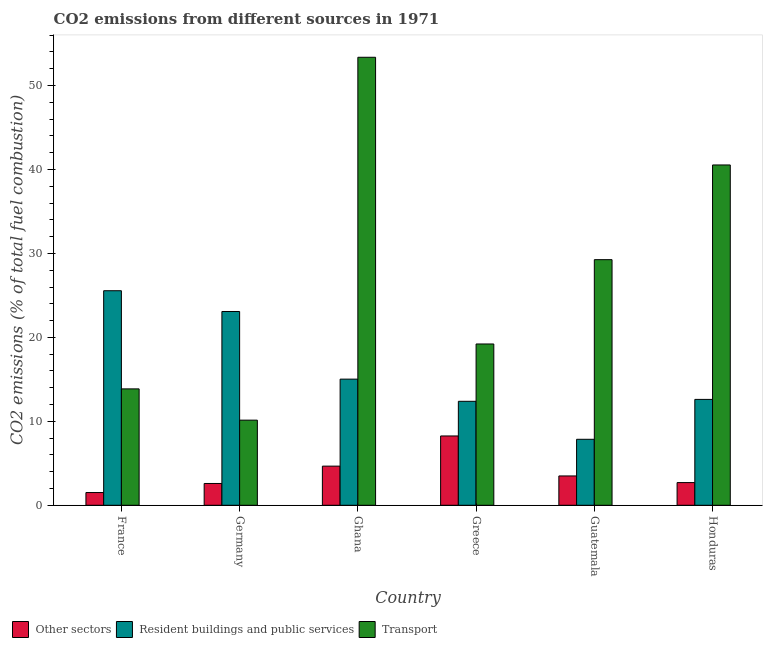How many groups of bars are there?
Your answer should be compact. 6. In how many cases, is the number of bars for a given country not equal to the number of legend labels?
Provide a succinct answer. 0. What is the percentage of co2 emissions from resident buildings and public services in Honduras?
Your answer should be very brief. 12.61. Across all countries, what is the maximum percentage of co2 emissions from transport?
Provide a succinct answer. 53.37. Across all countries, what is the minimum percentage of co2 emissions from other sectors?
Your response must be concise. 1.52. What is the total percentage of co2 emissions from transport in the graph?
Your answer should be compact. 166.39. What is the difference between the percentage of co2 emissions from other sectors in Germany and that in Honduras?
Your answer should be compact. -0.11. What is the difference between the percentage of co2 emissions from resident buildings and public services in Honduras and the percentage of co2 emissions from other sectors in France?
Your response must be concise. 11.1. What is the average percentage of co2 emissions from other sectors per country?
Your answer should be compact. 3.87. What is the difference between the percentage of co2 emissions from transport and percentage of co2 emissions from resident buildings and public services in Greece?
Your response must be concise. 6.83. What is the ratio of the percentage of co2 emissions from other sectors in Ghana to that in Guatemala?
Provide a short and direct response. 1.33. What is the difference between the highest and the second highest percentage of co2 emissions from transport?
Your answer should be compact. 12.83. What is the difference between the highest and the lowest percentage of co2 emissions from transport?
Give a very brief answer. 43.23. What does the 3rd bar from the left in Ghana represents?
Ensure brevity in your answer.  Transport. What does the 2nd bar from the right in Honduras represents?
Your answer should be compact. Resident buildings and public services. How many bars are there?
Provide a short and direct response. 18. How many countries are there in the graph?
Your response must be concise. 6. What is the difference between two consecutive major ticks on the Y-axis?
Ensure brevity in your answer.  10. Does the graph contain grids?
Your response must be concise. No. Where does the legend appear in the graph?
Offer a very short reply. Bottom left. How are the legend labels stacked?
Give a very brief answer. Horizontal. What is the title of the graph?
Make the answer very short. CO2 emissions from different sources in 1971. What is the label or title of the Y-axis?
Your answer should be compact. CO2 emissions (% of total fuel combustion). What is the CO2 emissions (% of total fuel combustion) of Other sectors in France?
Your response must be concise. 1.52. What is the CO2 emissions (% of total fuel combustion) of Resident buildings and public services in France?
Provide a succinct answer. 25.56. What is the CO2 emissions (% of total fuel combustion) in Transport in France?
Provide a short and direct response. 13.86. What is the CO2 emissions (% of total fuel combustion) in Other sectors in Germany?
Offer a terse response. 2.6. What is the CO2 emissions (% of total fuel combustion) in Resident buildings and public services in Germany?
Provide a short and direct response. 23.08. What is the CO2 emissions (% of total fuel combustion) of Transport in Germany?
Give a very brief answer. 10.14. What is the CO2 emissions (% of total fuel combustion) of Other sectors in Ghana?
Your response must be concise. 4.66. What is the CO2 emissions (% of total fuel combustion) in Resident buildings and public services in Ghana?
Give a very brief answer. 15.03. What is the CO2 emissions (% of total fuel combustion) in Transport in Ghana?
Keep it short and to the point. 53.37. What is the CO2 emissions (% of total fuel combustion) of Other sectors in Greece?
Offer a very short reply. 8.26. What is the CO2 emissions (% of total fuel combustion) in Resident buildings and public services in Greece?
Your answer should be compact. 12.39. What is the CO2 emissions (% of total fuel combustion) in Transport in Greece?
Ensure brevity in your answer.  19.21. What is the CO2 emissions (% of total fuel combustion) in Other sectors in Guatemala?
Ensure brevity in your answer.  3.49. What is the CO2 emissions (% of total fuel combustion) in Resident buildings and public services in Guatemala?
Offer a very short reply. 7.86. What is the CO2 emissions (% of total fuel combustion) in Transport in Guatemala?
Provide a succinct answer. 29.26. What is the CO2 emissions (% of total fuel combustion) of Other sectors in Honduras?
Your answer should be compact. 2.7. What is the CO2 emissions (% of total fuel combustion) of Resident buildings and public services in Honduras?
Make the answer very short. 12.61. What is the CO2 emissions (% of total fuel combustion) of Transport in Honduras?
Your answer should be compact. 40.54. Across all countries, what is the maximum CO2 emissions (% of total fuel combustion) of Other sectors?
Your response must be concise. 8.26. Across all countries, what is the maximum CO2 emissions (% of total fuel combustion) in Resident buildings and public services?
Keep it short and to the point. 25.56. Across all countries, what is the maximum CO2 emissions (% of total fuel combustion) of Transport?
Your answer should be very brief. 53.37. Across all countries, what is the minimum CO2 emissions (% of total fuel combustion) in Other sectors?
Give a very brief answer. 1.52. Across all countries, what is the minimum CO2 emissions (% of total fuel combustion) in Resident buildings and public services?
Give a very brief answer. 7.86. Across all countries, what is the minimum CO2 emissions (% of total fuel combustion) in Transport?
Your response must be concise. 10.14. What is the total CO2 emissions (% of total fuel combustion) of Other sectors in the graph?
Offer a terse response. 23.23. What is the total CO2 emissions (% of total fuel combustion) in Resident buildings and public services in the graph?
Keep it short and to the point. 96.53. What is the total CO2 emissions (% of total fuel combustion) of Transport in the graph?
Make the answer very short. 166.39. What is the difference between the CO2 emissions (% of total fuel combustion) in Other sectors in France and that in Germany?
Give a very brief answer. -1.08. What is the difference between the CO2 emissions (% of total fuel combustion) of Resident buildings and public services in France and that in Germany?
Ensure brevity in your answer.  2.47. What is the difference between the CO2 emissions (% of total fuel combustion) of Transport in France and that in Germany?
Your answer should be compact. 3.72. What is the difference between the CO2 emissions (% of total fuel combustion) in Other sectors in France and that in Ghana?
Make the answer very short. -3.15. What is the difference between the CO2 emissions (% of total fuel combustion) of Resident buildings and public services in France and that in Ghana?
Keep it short and to the point. 10.53. What is the difference between the CO2 emissions (% of total fuel combustion) of Transport in France and that in Ghana?
Your answer should be compact. -39.5. What is the difference between the CO2 emissions (% of total fuel combustion) of Other sectors in France and that in Greece?
Provide a succinct answer. -6.74. What is the difference between the CO2 emissions (% of total fuel combustion) of Resident buildings and public services in France and that in Greece?
Ensure brevity in your answer.  13.17. What is the difference between the CO2 emissions (% of total fuel combustion) of Transport in France and that in Greece?
Offer a terse response. -5.35. What is the difference between the CO2 emissions (% of total fuel combustion) in Other sectors in France and that in Guatemala?
Make the answer very short. -1.98. What is the difference between the CO2 emissions (% of total fuel combustion) of Resident buildings and public services in France and that in Guatemala?
Give a very brief answer. 17.7. What is the difference between the CO2 emissions (% of total fuel combustion) of Transport in France and that in Guatemala?
Your response must be concise. -15.39. What is the difference between the CO2 emissions (% of total fuel combustion) of Other sectors in France and that in Honduras?
Your response must be concise. -1.19. What is the difference between the CO2 emissions (% of total fuel combustion) in Resident buildings and public services in France and that in Honduras?
Your response must be concise. 12.94. What is the difference between the CO2 emissions (% of total fuel combustion) in Transport in France and that in Honduras?
Your answer should be compact. -26.68. What is the difference between the CO2 emissions (% of total fuel combustion) in Other sectors in Germany and that in Ghana?
Offer a very short reply. -2.07. What is the difference between the CO2 emissions (% of total fuel combustion) in Resident buildings and public services in Germany and that in Ghana?
Provide a succinct answer. 8.06. What is the difference between the CO2 emissions (% of total fuel combustion) of Transport in Germany and that in Ghana?
Provide a succinct answer. -43.23. What is the difference between the CO2 emissions (% of total fuel combustion) in Other sectors in Germany and that in Greece?
Keep it short and to the point. -5.66. What is the difference between the CO2 emissions (% of total fuel combustion) of Resident buildings and public services in Germany and that in Greece?
Give a very brief answer. 10.7. What is the difference between the CO2 emissions (% of total fuel combustion) in Transport in Germany and that in Greece?
Make the answer very short. -9.07. What is the difference between the CO2 emissions (% of total fuel combustion) in Other sectors in Germany and that in Guatemala?
Offer a terse response. -0.9. What is the difference between the CO2 emissions (% of total fuel combustion) of Resident buildings and public services in Germany and that in Guatemala?
Provide a short and direct response. 15.22. What is the difference between the CO2 emissions (% of total fuel combustion) of Transport in Germany and that in Guatemala?
Provide a short and direct response. -19.12. What is the difference between the CO2 emissions (% of total fuel combustion) in Other sectors in Germany and that in Honduras?
Offer a terse response. -0.11. What is the difference between the CO2 emissions (% of total fuel combustion) of Resident buildings and public services in Germany and that in Honduras?
Offer a terse response. 10.47. What is the difference between the CO2 emissions (% of total fuel combustion) in Transport in Germany and that in Honduras?
Give a very brief answer. -30.4. What is the difference between the CO2 emissions (% of total fuel combustion) in Other sectors in Ghana and that in Greece?
Your answer should be very brief. -3.59. What is the difference between the CO2 emissions (% of total fuel combustion) of Resident buildings and public services in Ghana and that in Greece?
Ensure brevity in your answer.  2.64. What is the difference between the CO2 emissions (% of total fuel combustion) in Transport in Ghana and that in Greece?
Keep it short and to the point. 34.15. What is the difference between the CO2 emissions (% of total fuel combustion) of Other sectors in Ghana and that in Guatemala?
Offer a very short reply. 1.17. What is the difference between the CO2 emissions (% of total fuel combustion) in Resident buildings and public services in Ghana and that in Guatemala?
Offer a very short reply. 7.17. What is the difference between the CO2 emissions (% of total fuel combustion) of Transport in Ghana and that in Guatemala?
Ensure brevity in your answer.  24.11. What is the difference between the CO2 emissions (% of total fuel combustion) of Other sectors in Ghana and that in Honduras?
Ensure brevity in your answer.  1.96. What is the difference between the CO2 emissions (% of total fuel combustion) in Resident buildings and public services in Ghana and that in Honduras?
Offer a very short reply. 2.41. What is the difference between the CO2 emissions (% of total fuel combustion) in Transport in Ghana and that in Honduras?
Keep it short and to the point. 12.83. What is the difference between the CO2 emissions (% of total fuel combustion) in Other sectors in Greece and that in Guatemala?
Ensure brevity in your answer.  4.76. What is the difference between the CO2 emissions (% of total fuel combustion) in Resident buildings and public services in Greece and that in Guatemala?
Provide a short and direct response. 4.53. What is the difference between the CO2 emissions (% of total fuel combustion) in Transport in Greece and that in Guatemala?
Your answer should be compact. -10.04. What is the difference between the CO2 emissions (% of total fuel combustion) in Other sectors in Greece and that in Honduras?
Keep it short and to the point. 5.55. What is the difference between the CO2 emissions (% of total fuel combustion) in Resident buildings and public services in Greece and that in Honduras?
Provide a short and direct response. -0.23. What is the difference between the CO2 emissions (% of total fuel combustion) in Transport in Greece and that in Honduras?
Offer a terse response. -21.33. What is the difference between the CO2 emissions (% of total fuel combustion) in Other sectors in Guatemala and that in Honduras?
Keep it short and to the point. 0.79. What is the difference between the CO2 emissions (% of total fuel combustion) in Resident buildings and public services in Guatemala and that in Honduras?
Offer a very short reply. -4.75. What is the difference between the CO2 emissions (% of total fuel combustion) of Transport in Guatemala and that in Honduras?
Offer a very short reply. -11.28. What is the difference between the CO2 emissions (% of total fuel combustion) in Other sectors in France and the CO2 emissions (% of total fuel combustion) in Resident buildings and public services in Germany?
Make the answer very short. -21.57. What is the difference between the CO2 emissions (% of total fuel combustion) in Other sectors in France and the CO2 emissions (% of total fuel combustion) in Transport in Germany?
Provide a succinct answer. -8.62. What is the difference between the CO2 emissions (% of total fuel combustion) in Resident buildings and public services in France and the CO2 emissions (% of total fuel combustion) in Transport in Germany?
Ensure brevity in your answer.  15.42. What is the difference between the CO2 emissions (% of total fuel combustion) of Other sectors in France and the CO2 emissions (% of total fuel combustion) of Resident buildings and public services in Ghana?
Your answer should be very brief. -13.51. What is the difference between the CO2 emissions (% of total fuel combustion) of Other sectors in France and the CO2 emissions (% of total fuel combustion) of Transport in Ghana?
Make the answer very short. -51.85. What is the difference between the CO2 emissions (% of total fuel combustion) in Resident buildings and public services in France and the CO2 emissions (% of total fuel combustion) in Transport in Ghana?
Keep it short and to the point. -27.81. What is the difference between the CO2 emissions (% of total fuel combustion) in Other sectors in France and the CO2 emissions (% of total fuel combustion) in Resident buildings and public services in Greece?
Offer a very short reply. -10.87. What is the difference between the CO2 emissions (% of total fuel combustion) in Other sectors in France and the CO2 emissions (% of total fuel combustion) in Transport in Greece?
Provide a succinct answer. -17.7. What is the difference between the CO2 emissions (% of total fuel combustion) in Resident buildings and public services in France and the CO2 emissions (% of total fuel combustion) in Transport in Greece?
Ensure brevity in your answer.  6.34. What is the difference between the CO2 emissions (% of total fuel combustion) in Other sectors in France and the CO2 emissions (% of total fuel combustion) in Resident buildings and public services in Guatemala?
Your answer should be compact. -6.34. What is the difference between the CO2 emissions (% of total fuel combustion) of Other sectors in France and the CO2 emissions (% of total fuel combustion) of Transport in Guatemala?
Keep it short and to the point. -27.74. What is the difference between the CO2 emissions (% of total fuel combustion) in Resident buildings and public services in France and the CO2 emissions (% of total fuel combustion) in Transport in Guatemala?
Keep it short and to the point. -3.7. What is the difference between the CO2 emissions (% of total fuel combustion) of Other sectors in France and the CO2 emissions (% of total fuel combustion) of Resident buildings and public services in Honduras?
Ensure brevity in your answer.  -11.1. What is the difference between the CO2 emissions (% of total fuel combustion) in Other sectors in France and the CO2 emissions (% of total fuel combustion) in Transport in Honduras?
Your answer should be compact. -39.02. What is the difference between the CO2 emissions (% of total fuel combustion) of Resident buildings and public services in France and the CO2 emissions (% of total fuel combustion) of Transport in Honduras?
Provide a short and direct response. -14.98. What is the difference between the CO2 emissions (% of total fuel combustion) of Other sectors in Germany and the CO2 emissions (% of total fuel combustion) of Resident buildings and public services in Ghana?
Offer a terse response. -12.43. What is the difference between the CO2 emissions (% of total fuel combustion) of Other sectors in Germany and the CO2 emissions (% of total fuel combustion) of Transport in Ghana?
Keep it short and to the point. -50.77. What is the difference between the CO2 emissions (% of total fuel combustion) of Resident buildings and public services in Germany and the CO2 emissions (% of total fuel combustion) of Transport in Ghana?
Ensure brevity in your answer.  -30.28. What is the difference between the CO2 emissions (% of total fuel combustion) of Other sectors in Germany and the CO2 emissions (% of total fuel combustion) of Resident buildings and public services in Greece?
Ensure brevity in your answer.  -9.79. What is the difference between the CO2 emissions (% of total fuel combustion) of Other sectors in Germany and the CO2 emissions (% of total fuel combustion) of Transport in Greece?
Your answer should be very brief. -16.62. What is the difference between the CO2 emissions (% of total fuel combustion) in Resident buildings and public services in Germany and the CO2 emissions (% of total fuel combustion) in Transport in Greece?
Provide a succinct answer. 3.87. What is the difference between the CO2 emissions (% of total fuel combustion) of Other sectors in Germany and the CO2 emissions (% of total fuel combustion) of Resident buildings and public services in Guatemala?
Ensure brevity in your answer.  -5.26. What is the difference between the CO2 emissions (% of total fuel combustion) in Other sectors in Germany and the CO2 emissions (% of total fuel combustion) in Transport in Guatemala?
Ensure brevity in your answer.  -26.66. What is the difference between the CO2 emissions (% of total fuel combustion) in Resident buildings and public services in Germany and the CO2 emissions (% of total fuel combustion) in Transport in Guatemala?
Keep it short and to the point. -6.17. What is the difference between the CO2 emissions (% of total fuel combustion) of Other sectors in Germany and the CO2 emissions (% of total fuel combustion) of Resident buildings and public services in Honduras?
Provide a succinct answer. -10.02. What is the difference between the CO2 emissions (% of total fuel combustion) in Other sectors in Germany and the CO2 emissions (% of total fuel combustion) in Transport in Honduras?
Keep it short and to the point. -37.94. What is the difference between the CO2 emissions (% of total fuel combustion) in Resident buildings and public services in Germany and the CO2 emissions (% of total fuel combustion) in Transport in Honduras?
Provide a succinct answer. -17.46. What is the difference between the CO2 emissions (% of total fuel combustion) in Other sectors in Ghana and the CO2 emissions (% of total fuel combustion) in Resident buildings and public services in Greece?
Offer a terse response. -7.72. What is the difference between the CO2 emissions (% of total fuel combustion) of Other sectors in Ghana and the CO2 emissions (% of total fuel combustion) of Transport in Greece?
Your answer should be compact. -14.55. What is the difference between the CO2 emissions (% of total fuel combustion) of Resident buildings and public services in Ghana and the CO2 emissions (% of total fuel combustion) of Transport in Greece?
Offer a very short reply. -4.19. What is the difference between the CO2 emissions (% of total fuel combustion) in Other sectors in Ghana and the CO2 emissions (% of total fuel combustion) in Resident buildings and public services in Guatemala?
Make the answer very short. -3.2. What is the difference between the CO2 emissions (% of total fuel combustion) in Other sectors in Ghana and the CO2 emissions (% of total fuel combustion) in Transport in Guatemala?
Offer a terse response. -24.59. What is the difference between the CO2 emissions (% of total fuel combustion) in Resident buildings and public services in Ghana and the CO2 emissions (% of total fuel combustion) in Transport in Guatemala?
Your answer should be very brief. -14.23. What is the difference between the CO2 emissions (% of total fuel combustion) in Other sectors in Ghana and the CO2 emissions (% of total fuel combustion) in Resident buildings and public services in Honduras?
Make the answer very short. -7.95. What is the difference between the CO2 emissions (% of total fuel combustion) of Other sectors in Ghana and the CO2 emissions (% of total fuel combustion) of Transport in Honduras?
Ensure brevity in your answer.  -35.88. What is the difference between the CO2 emissions (% of total fuel combustion) of Resident buildings and public services in Ghana and the CO2 emissions (% of total fuel combustion) of Transport in Honduras?
Give a very brief answer. -25.51. What is the difference between the CO2 emissions (% of total fuel combustion) in Other sectors in Greece and the CO2 emissions (% of total fuel combustion) in Resident buildings and public services in Guatemala?
Provide a short and direct response. 0.4. What is the difference between the CO2 emissions (% of total fuel combustion) in Other sectors in Greece and the CO2 emissions (% of total fuel combustion) in Transport in Guatemala?
Make the answer very short. -21. What is the difference between the CO2 emissions (% of total fuel combustion) of Resident buildings and public services in Greece and the CO2 emissions (% of total fuel combustion) of Transport in Guatemala?
Offer a terse response. -16.87. What is the difference between the CO2 emissions (% of total fuel combustion) in Other sectors in Greece and the CO2 emissions (% of total fuel combustion) in Resident buildings and public services in Honduras?
Provide a short and direct response. -4.36. What is the difference between the CO2 emissions (% of total fuel combustion) of Other sectors in Greece and the CO2 emissions (% of total fuel combustion) of Transport in Honduras?
Offer a very short reply. -32.28. What is the difference between the CO2 emissions (% of total fuel combustion) of Resident buildings and public services in Greece and the CO2 emissions (% of total fuel combustion) of Transport in Honduras?
Provide a succinct answer. -28.15. What is the difference between the CO2 emissions (% of total fuel combustion) of Other sectors in Guatemala and the CO2 emissions (% of total fuel combustion) of Resident buildings and public services in Honduras?
Provide a succinct answer. -9.12. What is the difference between the CO2 emissions (% of total fuel combustion) in Other sectors in Guatemala and the CO2 emissions (% of total fuel combustion) in Transport in Honduras?
Give a very brief answer. -37.05. What is the difference between the CO2 emissions (% of total fuel combustion) in Resident buildings and public services in Guatemala and the CO2 emissions (% of total fuel combustion) in Transport in Honduras?
Offer a terse response. -32.68. What is the average CO2 emissions (% of total fuel combustion) in Other sectors per country?
Your answer should be compact. 3.87. What is the average CO2 emissions (% of total fuel combustion) of Resident buildings and public services per country?
Your response must be concise. 16.09. What is the average CO2 emissions (% of total fuel combustion) of Transport per country?
Ensure brevity in your answer.  27.73. What is the difference between the CO2 emissions (% of total fuel combustion) in Other sectors and CO2 emissions (% of total fuel combustion) in Resident buildings and public services in France?
Offer a terse response. -24.04. What is the difference between the CO2 emissions (% of total fuel combustion) in Other sectors and CO2 emissions (% of total fuel combustion) in Transport in France?
Your answer should be very brief. -12.35. What is the difference between the CO2 emissions (% of total fuel combustion) in Resident buildings and public services and CO2 emissions (% of total fuel combustion) in Transport in France?
Make the answer very short. 11.69. What is the difference between the CO2 emissions (% of total fuel combustion) in Other sectors and CO2 emissions (% of total fuel combustion) in Resident buildings and public services in Germany?
Give a very brief answer. -20.49. What is the difference between the CO2 emissions (% of total fuel combustion) of Other sectors and CO2 emissions (% of total fuel combustion) of Transport in Germany?
Offer a very short reply. -7.54. What is the difference between the CO2 emissions (% of total fuel combustion) of Resident buildings and public services and CO2 emissions (% of total fuel combustion) of Transport in Germany?
Provide a short and direct response. 12.94. What is the difference between the CO2 emissions (% of total fuel combustion) in Other sectors and CO2 emissions (% of total fuel combustion) in Resident buildings and public services in Ghana?
Your response must be concise. -10.36. What is the difference between the CO2 emissions (% of total fuel combustion) in Other sectors and CO2 emissions (% of total fuel combustion) in Transport in Ghana?
Provide a short and direct response. -48.7. What is the difference between the CO2 emissions (% of total fuel combustion) of Resident buildings and public services and CO2 emissions (% of total fuel combustion) of Transport in Ghana?
Ensure brevity in your answer.  -38.34. What is the difference between the CO2 emissions (% of total fuel combustion) in Other sectors and CO2 emissions (% of total fuel combustion) in Resident buildings and public services in Greece?
Your answer should be very brief. -4.13. What is the difference between the CO2 emissions (% of total fuel combustion) of Other sectors and CO2 emissions (% of total fuel combustion) of Transport in Greece?
Your answer should be compact. -10.96. What is the difference between the CO2 emissions (% of total fuel combustion) in Resident buildings and public services and CO2 emissions (% of total fuel combustion) in Transport in Greece?
Your answer should be very brief. -6.83. What is the difference between the CO2 emissions (% of total fuel combustion) of Other sectors and CO2 emissions (% of total fuel combustion) of Resident buildings and public services in Guatemala?
Offer a very short reply. -4.37. What is the difference between the CO2 emissions (% of total fuel combustion) in Other sectors and CO2 emissions (% of total fuel combustion) in Transport in Guatemala?
Offer a terse response. -25.76. What is the difference between the CO2 emissions (% of total fuel combustion) of Resident buildings and public services and CO2 emissions (% of total fuel combustion) of Transport in Guatemala?
Provide a short and direct response. -21.4. What is the difference between the CO2 emissions (% of total fuel combustion) in Other sectors and CO2 emissions (% of total fuel combustion) in Resident buildings and public services in Honduras?
Provide a succinct answer. -9.91. What is the difference between the CO2 emissions (% of total fuel combustion) in Other sectors and CO2 emissions (% of total fuel combustion) in Transport in Honduras?
Your answer should be very brief. -37.84. What is the difference between the CO2 emissions (% of total fuel combustion) in Resident buildings and public services and CO2 emissions (% of total fuel combustion) in Transport in Honduras?
Offer a terse response. -27.93. What is the ratio of the CO2 emissions (% of total fuel combustion) of Other sectors in France to that in Germany?
Provide a short and direct response. 0.58. What is the ratio of the CO2 emissions (% of total fuel combustion) of Resident buildings and public services in France to that in Germany?
Offer a very short reply. 1.11. What is the ratio of the CO2 emissions (% of total fuel combustion) in Transport in France to that in Germany?
Offer a very short reply. 1.37. What is the ratio of the CO2 emissions (% of total fuel combustion) of Other sectors in France to that in Ghana?
Give a very brief answer. 0.33. What is the ratio of the CO2 emissions (% of total fuel combustion) in Resident buildings and public services in France to that in Ghana?
Ensure brevity in your answer.  1.7. What is the ratio of the CO2 emissions (% of total fuel combustion) in Transport in France to that in Ghana?
Make the answer very short. 0.26. What is the ratio of the CO2 emissions (% of total fuel combustion) in Other sectors in France to that in Greece?
Give a very brief answer. 0.18. What is the ratio of the CO2 emissions (% of total fuel combustion) of Resident buildings and public services in France to that in Greece?
Keep it short and to the point. 2.06. What is the ratio of the CO2 emissions (% of total fuel combustion) in Transport in France to that in Greece?
Keep it short and to the point. 0.72. What is the ratio of the CO2 emissions (% of total fuel combustion) in Other sectors in France to that in Guatemala?
Ensure brevity in your answer.  0.43. What is the ratio of the CO2 emissions (% of total fuel combustion) of Resident buildings and public services in France to that in Guatemala?
Provide a succinct answer. 3.25. What is the ratio of the CO2 emissions (% of total fuel combustion) of Transport in France to that in Guatemala?
Keep it short and to the point. 0.47. What is the ratio of the CO2 emissions (% of total fuel combustion) in Other sectors in France to that in Honduras?
Make the answer very short. 0.56. What is the ratio of the CO2 emissions (% of total fuel combustion) of Resident buildings and public services in France to that in Honduras?
Provide a short and direct response. 2.03. What is the ratio of the CO2 emissions (% of total fuel combustion) of Transport in France to that in Honduras?
Offer a very short reply. 0.34. What is the ratio of the CO2 emissions (% of total fuel combustion) of Other sectors in Germany to that in Ghana?
Keep it short and to the point. 0.56. What is the ratio of the CO2 emissions (% of total fuel combustion) in Resident buildings and public services in Germany to that in Ghana?
Offer a terse response. 1.54. What is the ratio of the CO2 emissions (% of total fuel combustion) of Transport in Germany to that in Ghana?
Offer a very short reply. 0.19. What is the ratio of the CO2 emissions (% of total fuel combustion) in Other sectors in Germany to that in Greece?
Your response must be concise. 0.31. What is the ratio of the CO2 emissions (% of total fuel combustion) of Resident buildings and public services in Germany to that in Greece?
Offer a terse response. 1.86. What is the ratio of the CO2 emissions (% of total fuel combustion) of Transport in Germany to that in Greece?
Provide a short and direct response. 0.53. What is the ratio of the CO2 emissions (% of total fuel combustion) in Other sectors in Germany to that in Guatemala?
Keep it short and to the point. 0.74. What is the ratio of the CO2 emissions (% of total fuel combustion) in Resident buildings and public services in Germany to that in Guatemala?
Your answer should be very brief. 2.94. What is the ratio of the CO2 emissions (% of total fuel combustion) in Transport in Germany to that in Guatemala?
Give a very brief answer. 0.35. What is the ratio of the CO2 emissions (% of total fuel combustion) in Other sectors in Germany to that in Honduras?
Give a very brief answer. 0.96. What is the ratio of the CO2 emissions (% of total fuel combustion) in Resident buildings and public services in Germany to that in Honduras?
Your response must be concise. 1.83. What is the ratio of the CO2 emissions (% of total fuel combustion) in Transport in Germany to that in Honduras?
Provide a succinct answer. 0.25. What is the ratio of the CO2 emissions (% of total fuel combustion) of Other sectors in Ghana to that in Greece?
Ensure brevity in your answer.  0.56. What is the ratio of the CO2 emissions (% of total fuel combustion) in Resident buildings and public services in Ghana to that in Greece?
Make the answer very short. 1.21. What is the ratio of the CO2 emissions (% of total fuel combustion) of Transport in Ghana to that in Greece?
Provide a succinct answer. 2.78. What is the ratio of the CO2 emissions (% of total fuel combustion) in Other sectors in Ghana to that in Guatemala?
Keep it short and to the point. 1.33. What is the ratio of the CO2 emissions (% of total fuel combustion) of Resident buildings and public services in Ghana to that in Guatemala?
Your answer should be very brief. 1.91. What is the ratio of the CO2 emissions (% of total fuel combustion) of Transport in Ghana to that in Guatemala?
Ensure brevity in your answer.  1.82. What is the ratio of the CO2 emissions (% of total fuel combustion) of Other sectors in Ghana to that in Honduras?
Make the answer very short. 1.73. What is the ratio of the CO2 emissions (% of total fuel combustion) of Resident buildings and public services in Ghana to that in Honduras?
Offer a terse response. 1.19. What is the ratio of the CO2 emissions (% of total fuel combustion) in Transport in Ghana to that in Honduras?
Make the answer very short. 1.32. What is the ratio of the CO2 emissions (% of total fuel combustion) of Other sectors in Greece to that in Guatemala?
Your answer should be compact. 2.36. What is the ratio of the CO2 emissions (% of total fuel combustion) in Resident buildings and public services in Greece to that in Guatemala?
Give a very brief answer. 1.58. What is the ratio of the CO2 emissions (% of total fuel combustion) of Transport in Greece to that in Guatemala?
Your response must be concise. 0.66. What is the ratio of the CO2 emissions (% of total fuel combustion) in Other sectors in Greece to that in Honduras?
Provide a succinct answer. 3.06. What is the ratio of the CO2 emissions (% of total fuel combustion) in Resident buildings and public services in Greece to that in Honduras?
Your answer should be very brief. 0.98. What is the ratio of the CO2 emissions (% of total fuel combustion) in Transport in Greece to that in Honduras?
Keep it short and to the point. 0.47. What is the ratio of the CO2 emissions (% of total fuel combustion) of Other sectors in Guatemala to that in Honduras?
Provide a succinct answer. 1.29. What is the ratio of the CO2 emissions (% of total fuel combustion) of Resident buildings and public services in Guatemala to that in Honduras?
Keep it short and to the point. 0.62. What is the ratio of the CO2 emissions (% of total fuel combustion) in Transport in Guatemala to that in Honduras?
Make the answer very short. 0.72. What is the difference between the highest and the second highest CO2 emissions (% of total fuel combustion) in Other sectors?
Offer a terse response. 3.59. What is the difference between the highest and the second highest CO2 emissions (% of total fuel combustion) in Resident buildings and public services?
Keep it short and to the point. 2.47. What is the difference between the highest and the second highest CO2 emissions (% of total fuel combustion) of Transport?
Offer a terse response. 12.83. What is the difference between the highest and the lowest CO2 emissions (% of total fuel combustion) of Other sectors?
Provide a short and direct response. 6.74. What is the difference between the highest and the lowest CO2 emissions (% of total fuel combustion) of Resident buildings and public services?
Ensure brevity in your answer.  17.7. What is the difference between the highest and the lowest CO2 emissions (% of total fuel combustion) of Transport?
Provide a succinct answer. 43.23. 